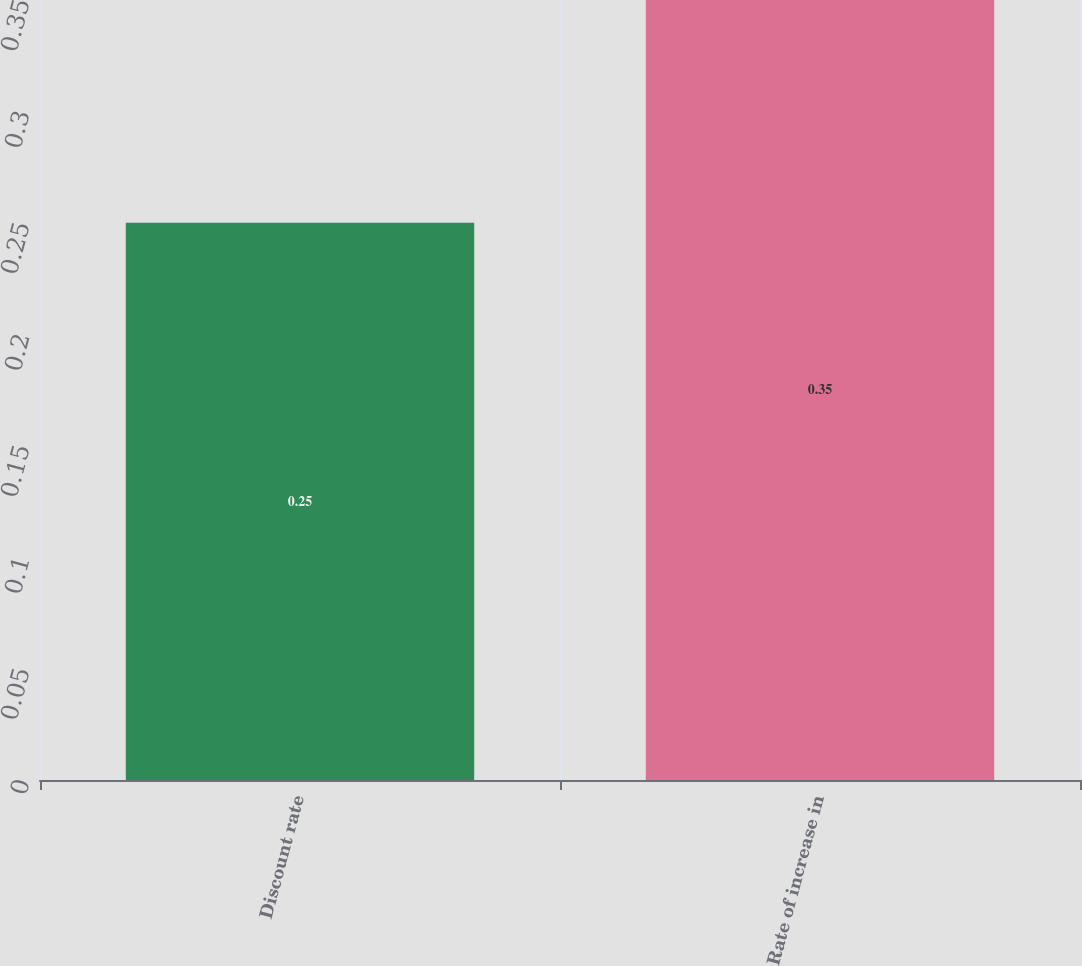Convert chart. <chart><loc_0><loc_0><loc_500><loc_500><bar_chart><fcel>Discount rate<fcel>Rate of increase in<nl><fcel>0.25<fcel>0.35<nl></chart> 